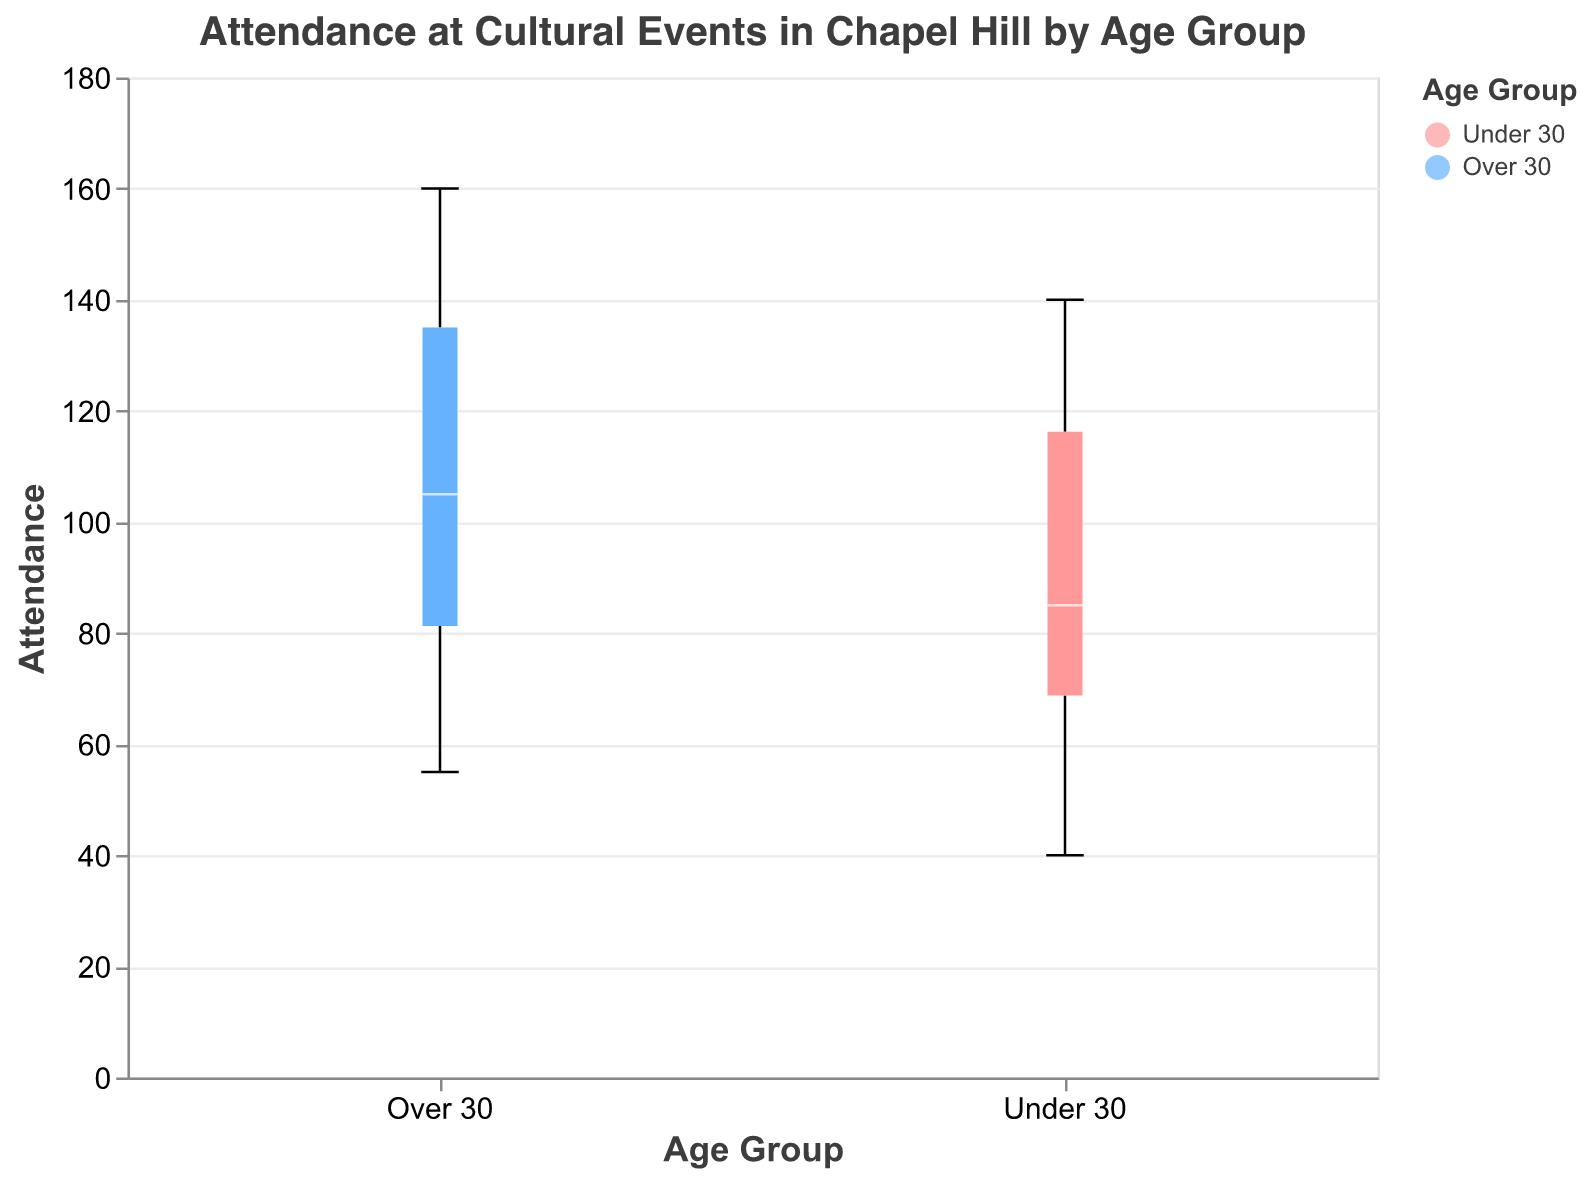What is the title of the figure? The title is mentioned at the top of the figure. It provides an overview of what the figure represents.
Answer: Attendance at Cultural Events in Chapel Hill by Age Group What are the age groups compared in the figure? The figure uses color and the x-axis label to show two distinct age groups.
Answer: Under 30, Over 30 Which event had the highest median attendance for the "Over 30" age group? You need to look at each box plot for the "Over 30" group and compare their median lines. The concert has the highest median.
Answer: Fridays on the Front Porch Concert What is the attendance range for "Under 30" at the Ackland Art Museum Exhibit? The range is from the minimum to the maximum value marked by the whiskers of the box plot.
Answer: 80 Which age group has higher attendance at the Morehead Planetarium Show? Compare the Morehead Planetarium Show box plots for both age groups.
Answer: Under 30 What is the median attendance for "Under 30" at the Carolina Performing Arts Show? Look for the median line inside the "Under 30" box for this event.
Answer: 120 Compare the attendance of "Under 30" and "Over 30" for the North Carolina Botanical Garden Tour and determine which group had more attendance. Compare the respective box plots for this event, noting their heights and medians.
Answer: Over 30 What is the difference in median attendance between "Under 30" and "Over 30" for Chapel Hill Public Library Event? Subtract the median value of "Under 30" from the median value of "Over 30" for this event.
Answer: 20 Which event shows the smallest attendance spread for the "Over 30" age group? The smallest spread is indicated by the shortest whiskers on the "Over 30" box plots.
Answer: PlayMakers Repertory Company Performance What general trend can be observed about attendance in different age groups? Observing the height of boxes and their position on the y-axis usually indicates the trend. Higher median values often signify higher attendance.
Answer: Over 30 has higher attendance in most events 